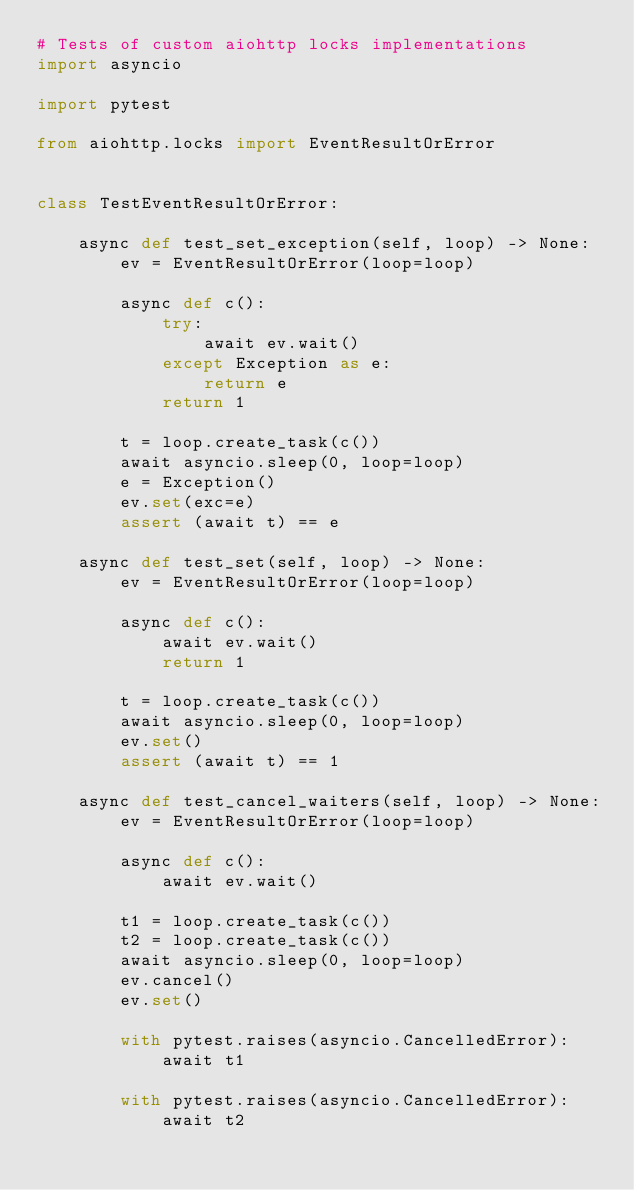Convert code to text. <code><loc_0><loc_0><loc_500><loc_500><_Python_># Tests of custom aiohttp locks implementations
import asyncio

import pytest

from aiohttp.locks import EventResultOrError


class TestEventResultOrError:

    async def test_set_exception(self, loop) -> None:
        ev = EventResultOrError(loop=loop)

        async def c():
            try:
                await ev.wait()
            except Exception as e:
                return e
            return 1

        t = loop.create_task(c())
        await asyncio.sleep(0, loop=loop)
        e = Exception()
        ev.set(exc=e)
        assert (await t) == e

    async def test_set(self, loop) -> None:
        ev = EventResultOrError(loop=loop)

        async def c():
            await ev.wait()
            return 1

        t = loop.create_task(c())
        await asyncio.sleep(0, loop=loop)
        ev.set()
        assert (await t) == 1

    async def test_cancel_waiters(self, loop) -> None:
        ev = EventResultOrError(loop=loop)

        async def c():
            await ev.wait()

        t1 = loop.create_task(c())
        t2 = loop.create_task(c())
        await asyncio.sleep(0, loop=loop)
        ev.cancel()
        ev.set()

        with pytest.raises(asyncio.CancelledError):
            await t1

        with pytest.raises(asyncio.CancelledError):
            await t2
</code> 